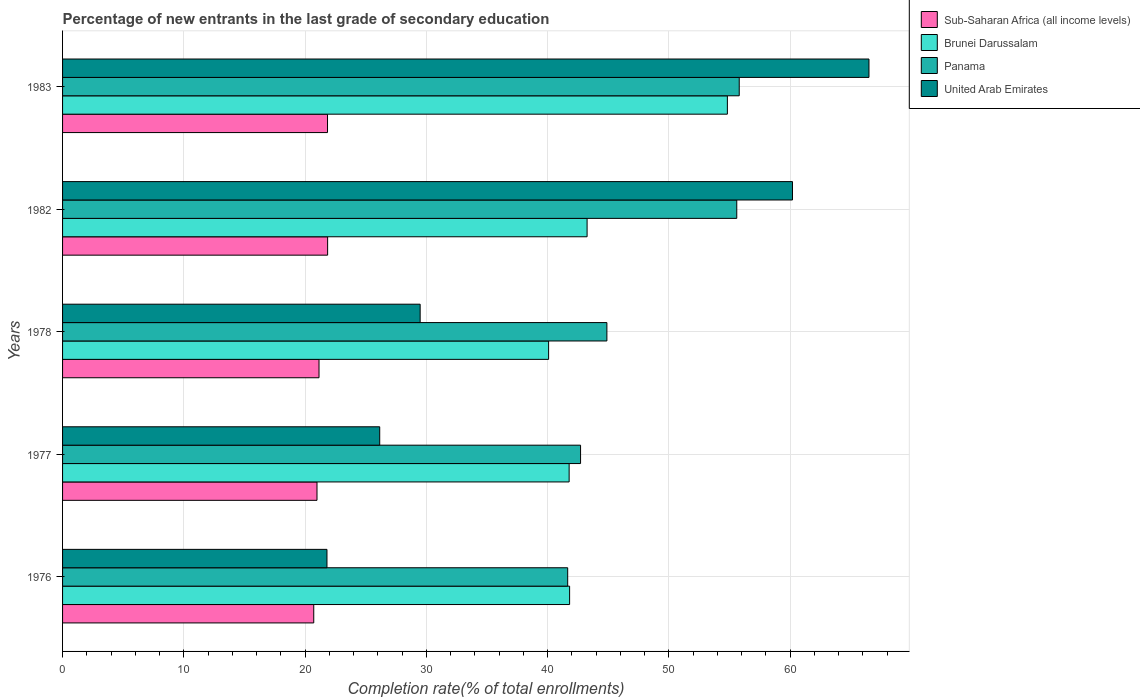How many different coloured bars are there?
Offer a terse response. 4. How many groups of bars are there?
Your response must be concise. 5. How many bars are there on the 5th tick from the bottom?
Your answer should be compact. 4. In how many cases, is the number of bars for a given year not equal to the number of legend labels?
Your response must be concise. 0. What is the percentage of new entrants in United Arab Emirates in 1982?
Offer a very short reply. 60.19. Across all years, what is the maximum percentage of new entrants in United Arab Emirates?
Your answer should be compact. 66.5. Across all years, what is the minimum percentage of new entrants in Sub-Saharan Africa (all income levels)?
Ensure brevity in your answer.  20.71. In which year was the percentage of new entrants in United Arab Emirates minimum?
Your response must be concise. 1976. What is the total percentage of new entrants in Panama in the graph?
Give a very brief answer. 240.66. What is the difference between the percentage of new entrants in Brunei Darussalam in 1976 and that in 1978?
Give a very brief answer. 1.73. What is the difference between the percentage of new entrants in United Arab Emirates in 1977 and the percentage of new entrants in Brunei Darussalam in 1983?
Ensure brevity in your answer.  -28.67. What is the average percentage of new entrants in Sub-Saharan Africa (all income levels) per year?
Provide a short and direct response. 21.31. In the year 1977, what is the difference between the percentage of new entrants in Sub-Saharan Africa (all income levels) and percentage of new entrants in Panama?
Offer a terse response. -21.73. In how many years, is the percentage of new entrants in United Arab Emirates greater than 12 %?
Your answer should be compact. 5. What is the ratio of the percentage of new entrants in United Arab Emirates in 1977 to that in 1982?
Keep it short and to the point. 0.43. Is the difference between the percentage of new entrants in Sub-Saharan Africa (all income levels) in 1976 and 1977 greater than the difference between the percentage of new entrants in Panama in 1976 and 1977?
Provide a short and direct response. Yes. What is the difference between the highest and the second highest percentage of new entrants in Sub-Saharan Africa (all income levels)?
Make the answer very short. 0.01. What is the difference between the highest and the lowest percentage of new entrants in Brunei Darussalam?
Provide a short and direct response. 14.74. Is the sum of the percentage of new entrants in United Arab Emirates in 1978 and 1983 greater than the maximum percentage of new entrants in Brunei Darussalam across all years?
Offer a very short reply. Yes. Is it the case that in every year, the sum of the percentage of new entrants in Brunei Darussalam and percentage of new entrants in Panama is greater than the sum of percentage of new entrants in United Arab Emirates and percentage of new entrants in Sub-Saharan Africa (all income levels)?
Your answer should be compact. No. What does the 3rd bar from the top in 1976 represents?
Ensure brevity in your answer.  Brunei Darussalam. What does the 3rd bar from the bottom in 1983 represents?
Give a very brief answer. Panama. Is it the case that in every year, the sum of the percentage of new entrants in United Arab Emirates and percentage of new entrants in Brunei Darussalam is greater than the percentage of new entrants in Panama?
Keep it short and to the point. Yes. How many bars are there?
Provide a succinct answer. 20. Are all the bars in the graph horizontal?
Keep it short and to the point. Yes. What is the difference between two consecutive major ticks on the X-axis?
Provide a succinct answer. 10. Are the values on the major ticks of X-axis written in scientific E-notation?
Your response must be concise. No. What is the title of the graph?
Offer a terse response. Percentage of new entrants in the last grade of secondary education. What is the label or title of the X-axis?
Give a very brief answer. Completion rate(% of total enrollments). What is the Completion rate(% of total enrollments) of Sub-Saharan Africa (all income levels) in 1976?
Make the answer very short. 20.71. What is the Completion rate(% of total enrollments) of Brunei Darussalam in 1976?
Ensure brevity in your answer.  41.81. What is the Completion rate(% of total enrollments) of Panama in 1976?
Ensure brevity in your answer.  41.65. What is the Completion rate(% of total enrollments) in United Arab Emirates in 1976?
Your answer should be very brief. 21.8. What is the Completion rate(% of total enrollments) of Sub-Saharan Africa (all income levels) in 1977?
Keep it short and to the point. 20.98. What is the Completion rate(% of total enrollments) of Brunei Darussalam in 1977?
Keep it short and to the point. 41.77. What is the Completion rate(% of total enrollments) in Panama in 1977?
Make the answer very short. 42.72. What is the Completion rate(% of total enrollments) of United Arab Emirates in 1977?
Provide a short and direct response. 26.15. What is the Completion rate(% of total enrollments) of Sub-Saharan Africa (all income levels) in 1978?
Your answer should be compact. 21.15. What is the Completion rate(% of total enrollments) in Brunei Darussalam in 1978?
Keep it short and to the point. 40.08. What is the Completion rate(% of total enrollments) in Panama in 1978?
Provide a short and direct response. 44.89. What is the Completion rate(% of total enrollments) of United Arab Emirates in 1978?
Provide a succinct answer. 29.49. What is the Completion rate(% of total enrollments) in Sub-Saharan Africa (all income levels) in 1982?
Make the answer very short. 21.86. What is the Completion rate(% of total enrollments) of Brunei Darussalam in 1982?
Give a very brief answer. 43.25. What is the Completion rate(% of total enrollments) of Panama in 1982?
Your response must be concise. 55.6. What is the Completion rate(% of total enrollments) of United Arab Emirates in 1982?
Provide a short and direct response. 60.19. What is the Completion rate(% of total enrollments) in Sub-Saharan Africa (all income levels) in 1983?
Your answer should be very brief. 21.85. What is the Completion rate(% of total enrollments) of Brunei Darussalam in 1983?
Your answer should be very brief. 54.82. What is the Completion rate(% of total enrollments) in Panama in 1983?
Your answer should be compact. 55.8. What is the Completion rate(% of total enrollments) of United Arab Emirates in 1983?
Your answer should be very brief. 66.5. Across all years, what is the maximum Completion rate(% of total enrollments) of Sub-Saharan Africa (all income levels)?
Keep it short and to the point. 21.86. Across all years, what is the maximum Completion rate(% of total enrollments) in Brunei Darussalam?
Offer a very short reply. 54.82. Across all years, what is the maximum Completion rate(% of total enrollments) in Panama?
Your response must be concise. 55.8. Across all years, what is the maximum Completion rate(% of total enrollments) of United Arab Emirates?
Provide a short and direct response. 66.5. Across all years, what is the minimum Completion rate(% of total enrollments) of Sub-Saharan Africa (all income levels)?
Offer a very short reply. 20.71. Across all years, what is the minimum Completion rate(% of total enrollments) of Brunei Darussalam?
Offer a very short reply. 40.08. Across all years, what is the minimum Completion rate(% of total enrollments) of Panama?
Keep it short and to the point. 41.65. Across all years, what is the minimum Completion rate(% of total enrollments) in United Arab Emirates?
Give a very brief answer. 21.8. What is the total Completion rate(% of total enrollments) of Sub-Saharan Africa (all income levels) in the graph?
Offer a terse response. 106.55. What is the total Completion rate(% of total enrollments) of Brunei Darussalam in the graph?
Your answer should be compact. 221.75. What is the total Completion rate(% of total enrollments) in Panama in the graph?
Offer a very short reply. 240.66. What is the total Completion rate(% of total enrollments) in United Arab Emirates in the graph?
Your response must be concise. 204.14. What is the difference between the Completion rate(% of total enrollments) in Sub-Saharan Africa (all income levels) in 1976 and that in 1977?
Offer a very short reply. -0.27. What is the difference between the Completion rate(% of total enrollments) of Brunei Darussalam in 1976 and that in 1977?
Keep it short and to the point. 0.04. What is the difference between the Completion rate(% of total enrollments) in Panama in 1976 and that in 1977?
Your response must be concise. -1.06. What is the difference between the Completion rate(% of total enrollments) of United Arab Emirates in 1976 and that in 1977?
Provide a succinct answer. -4.35. What is the difference between the Completion rate(% of total enrollments) of Sub-Saharan Africa (all income levels) in 1976 and that in 1978?
Your response must be concise. -0.43. What is the difference between the Completion rate(% of total enrollments) of Brunei Darussalam in 1976 and that in 1978?
Offer a terse response. 1.73. What is the difference between the Completion rate(% of total enrollments) of Panama in 1976 and that in 1978?
Make the answer very short. -3.23. What is the difference between the Completion rate(% of total enrollments) in United Arab Emirates in 1976 and that in 1978?
Offer a terse response. -7.68. What is the difference between the Completion rate(% of total enrollments) in Sub-Saharan Africa (all income levels) in 1976 and that in 1982?
Keep it short and to the point. -1.14. What is the difference between the Completion rate(% of total enrollments) of Brunei Darussalam in 1976 and that in 1982?
Provide a short and direct response. -1.44. What is the difference between the Completion rate(% of total enrollments) in Panama in 1976 and that in 1982?
Offer a terse response. -13.94. What is the difference between the Completion rate(% of total enrollments) of United Arab Emirates in 1976 and that in 1982?
Your answer should be very brief. -38.39. What is the difference between the Completion rate(% of total enrollments) of Sub-Saharan Africa (all income levels) in 1976 and that in 1983?
Provide a short and direct response. -1.14. What is the difference between the Completion rate(% of total enrollments) in Brunei Darussalam in 1976 and that in 1983?
Ensure brevity in your answer.  -13.01. What is the difference between the Completion rate(% of total enrollments) in Panama in 1976 and that in 1983?
Offer a very short reply. -14.15. What is the difference between the Completion rate(% of total enrollments) in United Arab Emirates in 1976 and that in 1983?
Keep it short and to the point. -44.7. What is the difference between the Completion rate(% of total enrollments) in Sub-Saharan Africa (all income levels) in 1977 and that in 1978?
Offer a terse response. -0.17. What is the difference between the Completion rate(% of total enrollments) of Brunei Darussalam in 1977 and that in 1978?
Ensure brevity in your answer.  1.69. What is the difference between the Completion rate(% of total enrollments) in Panama in 1977 and that in 1978?
Provide a short and direct response. -2.17. What is the difference between the Completion rate(% of total enrollments) in United Arab Emirates in 1977 and that in 1978?
Your response must be concise. -3.33. What is the difference between the Completion rate(% of total enrollments) of Sub-Saharan Africa (all income levels) in 1977 and that in 1982?
Give a very brief answer. -0.88. What is the difference between the Completion rate(% of total enrollments) in Brunei Darussalam in 1977 and that in 1982?
Your response must be concise. -1.48. What is the difference between the Completion rate(% of total enrollments) of Panama in 1977 and that in 1982?
Your response must be concise. -12.88. What is the difference between the Completion rate(% of total enrollments) in United Arab Emirates in 1977 and that in 1982?
Your answer should be very brief. -34.04. What is the difference between the Completion rate(% of total enrollments) of Sub-Saharan Africa (all income levels) in 1977 and that in 1983?
Give a very brief answer. -0.87. What is the difference between the Completion rate(% of total enrollments) in Brunei Darussalam in 1977 and that in 1983?
Offer a very short reply. -13.05. What is the difference between the Completion rate(% of total enrollments) in Panama in 1977 and that in 1983?
Offer a terse response. -13.09. What is the difference between the Completion rate(% of total enrollments) of United Arab Emirates in 1977 and that in 1983?
Give a very brief answer. -40.35. What is the difference between the Completion rate(% of total enrollments) in Sub-Saharan Africa (all income levels) in 1978 and that in 1982?
Ensure brevity in your answer.  -0.71. What is the difference between the Completion rate(% of total enrollments) in Brunei Darussalam in 1978 and that in 1982?
Your response must be concise. -3.17. What is the difference between the Completion rate(% of total enrollments) of Panama in 1978 and that in 1982?
Give a very brief answer. -10.71. What is the difference between the Completion rate(% of total enrollments) of United Arab Emirates in 1978 and that in 1982?
Offer a very short reply. -30.7. What is the difference between the Completion rate(% of total enrollments) in Sub-Saharan Africa (all income levels) in 1978 and that in 1983?
Your answer should be compact. -0.7. What is the difference between the Completion rate(% of total enrollments) of Brunei Darussalam in 1978 and that in 1983?
Provide a succinct answer. -14.74. What is the difference between the Completion rate(% of total enrollments) of Panama in 1978 and that in 1983?
Offer a very short reply. -10.91. What is the difference between the Completion rate(% of total enrollments) in United Arab Emirates in 1978 and that in 1983?
Your answer should be very brief. -37.01. What is the difference between the Completion rate(% of total enrollments) in Sub-Saharan Africa (all income levels) in 1982 and that in 1983?
Provide a short and direct response. 0.01. What is the difference between the Completion rate(% of total enrollments) of Brunei Darussalam in 1982 and that in 1983?
Provide a short and direct response. -11.57. What is the difference between the Completion rate(% of total enrollments) in Panama in 1982 and that in 1983?
Give a very brief answer. -0.2. What is the difference between the Completion rate(% of total enrollments) of United Arab Emirates in 1982 and that in 1983?
Offer a very short reply. -6.31. What is the difference between the Completion rate(% of total enrollments) of Sub-Saharan Africa (all income levels) in 1976 and the Completion rate(% of total enrollments) of Brunei Darussalam in 1977?
Your answer should be very brief. -21.06. What is the difference between the Completion rate(% of total enrollments) of Sub-Saharan Africa (all income levels) in 1976 and the Completion rate(% of total enrollments) of Panama in 1977?
Keep it short and to the point. -22. What is the difference between the Completion rate(% of total enrollments) in Sub-Saharan Africa (all income levels) in 1976 and the Completion rate(% of total enrollments) in United Arab Emirates in 1977?
Give a very brief answer. -5.44. What is the difference between the Completion rate(% of total enrollments) of Brunei Darussalam in 1976 and the Completion rate(% of total enrollments) of Panama in 1977?
Your response must be concise. -0.9. What is the difference between the Completion rate(% of total enrollments) of Brunei Darussalam in 1976 and the Completion rate(% of total enrollments) of United Arab Emirates in 1977?
Your answer should be very brief. 15.66. What is the difference between the Completion rate(% of total enrollments) in Panama in 1976 and the Completion rate(% of total enrollments) in United Arab Emirates in 1977?
Your response must be concise. 15.5. What is the difference between the Completion rate(% of total enrollments) of Sub-Saharan Africa (all income levels) in 1976 and the Completion rate(% of total enrollments) of Brunei Darussalam in 1978?
Offer a very short reply. -19.37. What is the difference between the Completion rate(% of total enrollments) of Sub-Saharan Africa (all income levels) in 1976 and the Completion rate(% of total enrollments) of Panama in 1978?
Offer a very short reply. -24.17. What is the difference between the Completion rate(% of total enrollments) in Sub-Saharan Africa (all income levels) in 1976 and the Completion rate(% of total enrollments) in United Arab Emirates in 1978?
Ensure brevity in your answer.  -8.77. What is the difference between the Completion rate(% of total enrollments) in Brunei Darussalam in 1976 and the Completion rate(% of total enrollments) in Panama in 1978?
Keep it short and to the point. -3.07. What is the difference between the Completion rate(% of total enrollments) in Brunei Darussalam in 1976 and the Completion rate(% of total enrollments) in United Arab Emirates in 1978?
Make the answer very short. 12.33. What is the difference between the Completion rate(% of total enrollments) in Panama in 1976 and the Completion rate(% of total enrollments) in United Arab Emirates in 1978?
Provide a succinct answer. 12.17. What is the difference between the Completion rate(% of total enrollments) in Sub-Saharan Africa (all income levels) in 1976 and the Completion rate(% of total enrollments) in Brunei Darussalam in 1982?
Give a very brief answer. -22.54. What is the difference between the Completion rate(% of total enrollments) in Sub-Saharan Africa (all income levels) in 1976 and the Completion rate(% of total enrollments) in Panama in 1982?
Make the answer very short. -34.88. What is the difference between the Completion rate(% of total enrollments) in Sub-Saharan Africa (all income levels) in 1976 and the Completion rate(% of total enrollments) in United Arab Emirates in 1982?
Make the answer very short. -39.48. What is the difference between the Completion rate(% of total enrollments) of Brunei Darussalam in 1976 and the Completion rate(% of total enrollments) of Panama in 1982?
Your response must be concise. -13.78. What is the difference between the Completion rate(% of total enrollments) of Brunei Darussalam in 1976 and the Completion rate(% of total enrollments) of United Arab Emirates in 1982?
Offer a very short reply. -18.38. What is the difference between the Completion rate(% of total enrollments) of Panama in 1976 and the Completion rate(% of total enrollments) of United Arab Emirates in 1982?
Your response must be concise. -18.54. What is the difference between the Completion rate(% of total enrollments) of Sub-Saharan Africa (all income levels) in 1976 and the Completion rate(% of total enrollments) of Brunei Darussalam in 1983?
Offer a very short reply. -34.11. What is the difference between the Completion rate(% of total enrollments) in Sub-Saharan Africa (all income levels) in 1976 and the Completion rate(% of total enrollments) in Panama in 1983?
Your answer should be compact. -35.09. What is the difference between the Completion rate(% of total enrollments) of Sub-Saharan Africa (all income levels) in 1976 and the Completion rate(% of total enrollments) of United Arab Emirates in 1983?
Make the answer very short. -45.79. What is the difference between the Completion rate(% of total enrollments) in Brunei Darussalam in 1976 and the Completion rate(% of total enrollments) in Panama in 1983?
Provide a short and direct response. -13.99. What is the difference between the Completion rate(% of total enrollments) in Brunei Darussalam in 1976 and the Completion rate(% of total enrollments) in United Arab Emirates in 1983?
Your answer should be very brief. -24.69. What is the difference between the Completion rate(% of total enrollments) of Panama in 1976 and the Completion rate(% of total enrollments) of United Arab Emirates in 1983?
Offer a terse response. -24.84. What is the difference between the Completion rate(% of total enrollments) of Sub-Saharan Africa (all income levels) in 1977 and the Completion rate(% of total enrollments) of Brunei Darussalam in 1978?
Your answer should be compact. -19.1. What is the difference between the Completion rate(% of total enrollments) in Sub-Saharan Africa (all income levels) in 1977 and the Completion rate(% of total enrollments) in Panama in 1978?
Provide a short and direct response. -23.91. What is the difference between the Completion rate(% of total enrollments) of Sub-Saharan Africa (all income levels) in 1977 and the Completion rate(% of total enrollments) of United Arab Emirates in 1978?
Give a very brief answer. -8.51. What is the difference between the Completion rate(% of total enrollments) in Brunei Darussalam in 1977 and the Completion rate(% of total enrollments) in Panama in 1978?
Your answer should be very brief. -3.11. What is the difference between the Completion rate(% of total enrollments) in Brunei Darussalam in 1977 and the Completion rate(% of total enrollments) in United Arab Emirates in 1978?
Offer a terse response. 12.29. What is the difference between the Completion rate(% of total enrollments) of Panama in 1977 and the Completion rate(% of total enrollments) of United Arab Emirates in 1978?
Your answer should be compact. 13.23. What is the difference between the Completion rate(% of total enrollments) in Sub-Saharan Africa (all income levels) in 1977 and the Completion rate(% of total enrollments) in Brunei Darussalam in 1982?
Your answer should be compact. -22.27. What is the difference between the Completion rate(% of total enrollments) of Sub-Saharan Africa (all income levels) in 1977 and the Completion rate(% of total enrollments) of Panama in 1982?
Make the answer very short. -34.62. What is the difference between the Completion rate(% of total enrollments) in Sub-Saharan Africa (all income levels) in 1977 and the Completion rate(% of total enrollments) in United Arab Emirates in 1982?
Give a very brief answer. -39.21. What is the difference between the Completion rate(% of total enrollments) in Brunei Darussalam in 1977 and the Completion rate(% of total enrollments) in Panama in 1982?
Offer a terse response. -13.82. What is the difference between the Completion rate(% of total enrollments) in Brunei Darussalam in 1977 and the Completion rate(% of total enrollments) in United Arab Emirates in 1982?
Your answer should be compact. -18.42. What is the difference between the Completion rate(% of total enrollments) in Panama in 1977 and the Completion rate(% of total enrollments) in United Arab Emirates in 1982?
Your answer should be compact. -17.48. What is the difference between the Completion rate(% of total enrollments) of Sub-Saharan Africa (all income levels) in 1977 and the Completion rate(% of total enrollments) of Brunei Darussalam in 1983?
Keep it short and to the point. -33.84. What is the difference between the Completion rate(% of total enrollments) in Sub-Saharan Africa (all income levels) in 1977 and the Completion rate(% of total enrollments) in Panama in 1983?
Your answer should be very brief. -34.82. What is the difference between the Completion rate(% of total enrollments) in Sub-Saharan Africa (all income levels) in 1977 and the Completion rate(% of total enrollments) in United Arab Emirates in 1983?
Your answer should be very brief. -45.52. What is the difference between the Completion rate(% of total enrollments) in Brunei Darussalam in 1977 and the Completion rate(% of total enrollments) in Panama in 1983?
Your answer should be compact. -14.03. What is the difference between the Completion rate(% of total enrollments) in Brunei Darussalam in 1977 and the Completion rate(% of total enrollments) in United Arab Emirates in 1983?
Offer a terse response. -24.73. What is the difference between the Completion rate(% of total enrollments) of Panama in 1977 and the Completion rate(% of total enrollments) of United Arab Emirates in 1983?
Make the answer very short. -23.78. What is the difference between the Completion rate(% of total enrollments) of Sub-Saharan Africa (all income levels) in 1978 and the Completion rate(% of total enrollments) of Brunei Darussalam in 1982?
Your answer should be very brief. -22.11. What is the difference between the Completion rate(% of total enrollments) of Sub-Saharan Africa (all income levels) in 1978 and the Completion rate(% of total enrollments) of Panama in 1982?
Provide a short and direct response. -34.45. What is the difference between the Completion rate(% of total enrollments) in Sub-Saharan Africa (all income levels) in 1978 and the Completion rate(% of total enrollments) in United Arab Emirates in 1982?
Ensure brevity in your answer.  -39.04. What is the difference between the Completion rate(% of total enrollments) in Brunei Darussalam in 1978 and the Completion rate(% of total enrollments) in Panama in 1982?
Keep it short and to the point. -15.52. What is the difference between the Completion rate(% of total enrollments) of Brunei Darussalam in 1978 and the Completion rate(% of total enrollments) of United Arab Emirates in 1982?
Make the answer very short. -20.11. What is the difference between the Completion rate(% of total enrollments) in Panama in 1978 and the Completion rate(% of total enrollments) in United Arab Emirates in 1982?
Provide a short and direct response. -15.3. What is the difference between the Completion rate(% of total enrollments) in Sub-Saharan Africa (all income levels) in 1978 and the Completion rate(% of total enrollments) in Brunei Darussalam in 1983?
Make the answer very short. -33.67. What is the difference between the Completion rate(% of total enrollments) in Sub-Saharan Africa (all income levels) in 1978 and the Completion rate(% of total enrollments) in Panama in 1983?
Provide a succinct answer. -34.65. What is the difference between the Completion rate(% of total enrollments) in Sub-Saharan Africa (all income levels) in 1978 and the Completion rate(% of total enrollments) in United Arab Emirates in 1983?
Your answer should be compact. -45.35. What is the difference between the Completion rate(% of total enrollments) in Brunei Darussalam in 1978 and the Completion rate(% of total enrollments) in Panama in 1983?
Your response must be concise. -15.72. What is the difference between the Completion rate(% of total enrollments) in Brunei Darussalam in 1978 and the Completion rate(% of total enrollments) in United Arab Emirates in 1983?
Provide a succinct answer. -26.42. What is the difference between the Completion rate(% of total enrollments) in Panama in 1978 and the Completion rate(% of total enrollments) in United Arab Emirates in 1983?
Offer a very short reply. -21.61. What is the difference between the Completion rate(% of total enrollments) in Sub-Saharan Africa (all income levels) in 1982 and the Completion rate(% of total enrollments) in Brunei Darussalam in 1983?
Provide a short and direct response. -32.97. What is the difference between the Completion rate(% of total enrollments) in Sub-Saharan Africa (all income levels) in 1982 and the Completion rate(% of total enrollments) in Panama in 1983?
Offer a terse response. -33.94. What is the difference between the Completion rate(% of total enrollments) of Sub-Saharan Africa (all income levels) in 1982 and the Completion rate(% of total enrollments) of United Arab Emirates in 1983?
Your answer should be compact. -44.64. What is the difference between the Completion rate(% of total enrollments) of Brunei Darussalam in 1982 and the Completion rate(% of total enrollments) of Panama in 1983?
Give a very brief answer. -12.55. What is the difference between the Completion rate(% of total enrollments) of Brunei Darussalam in 1982 and the Completion rate(% of total enrollments) of United Arab Emirates in 1983?
Make the answer very short. -23.24. What is the difference between the Completion rate(% of total enrollments) of Panama in 1982 and the Completion rate(% of total enrollments) of United Arab Emirates in 1983?
Your answer should be compact. -10.9. What is the average Completion rate(% of total enrollments) in Sub-Saharan Africa (all income levels) per year?
Provide a succinct answer. 21.31. What is the average Completion rate(% of total enrollments) in Brunei Darussalam per year?
Your answer should be very brief. 44.35. What is the average Completion rate(% of total enrollments) in Panama per year?
Your response must be concise. 48.13. What is the average Completion rate(% of total enrollments) of United Arab Emirates per year?
Offer a terse response. 40.83. In the year 1976, what is the difference between the Completion rate(% of total enrollments) in Sub-Saharan Africa (all income levels) and Completion rate(% of total enrollments) in Brunei Darussalam?
Make the answer very short. -21.1. In the year 1976, what is the difference between the Completion rate(% of total enrollments) of Sub-Saharan Africa (all income levels) and Completion rate(% of total enrollments) of Panama?
Provide a succinct answer. -20.94. In the year 1976, what is the difference between the Completion rate(% of total enrollments) of Sub-Saharan Africa (all income levels) and Completion rate(% of total enrollments) of United Arab Emirates?
Provide a short and direct response. -1.09. In the year 1976, what is the difference between the Completion rate(% of total enrollments) in Brunei Darussalam and Completion rate(% of total enrollments) in Panama?
Ensure brevity in your answer.  0.16. In the year 1976, what is the difference between the Completion rate(% of total enrollments) of Brunei Darussalam and Completion rate(% of total enrollments) of United Arab Emirates?
Provide a short and direct response. 20.01. In the year 1976, what is the difference between the Completion rate(% of total enrollments) in Panama and Completion rate(% of total enrollments) in United Arab Emirates?
Ensure brevity in your answer.  19.85. In the year 1977, what is the difference between the Completion rate(% of total enrollments) of Sub-Saharan Africa (all income levels) and Completion rate(% of total enrollments) of Brunei Darussalam?
Your response must be concise. -20.79. In the year 1977, what is the difference between the Completion rate(% of total enrollments) of Sub-Saharan Africa (all income levels) and Completion rate(% of total enrollments) of Panama?
Your response must be concise. -21.73. In the year 1977, what is the difference between the Completion rate(% of total enrollments) of Sub-Saharan Africa (all income levels) and Completion rate(% of total enrollments) of United Arab Emirates?
Offer a terse response. -5.17. In the year 1977, what is the difference between the Completion rate(% of total enrollments) of Brunei Darussalam and Completion rate(% of total enrollments) of Panama?
Ensure brevity in your answer.  -0.94. In the year 1977, what is the difference between the Completion rate(% of total enrollments) in Brunei Darussalam and Completion rate(% of total enrollments) in United Arab Emirates?
Provide a short and direct response. 15.62. In the year 1977, what is the difference between the Completion rate(% of total enrollments) in Panama and Completion rate(% of total enrollments) in United Arab Emirates?
Give a very brief answer. 16.56. In the year 1978, what is the difference between the Completion rate(% of total enrollments) in Sub-Saharan Africa (all income levels) and Completion rate(% of total enrollments) in Brunei Darussalam?
Your answer should be compact. -18.93. In the year 1978, what is the difference between the Completion rate(% of total enrollments) of Sub-Saharan Africa (all income levels) and Completion rate(% of total enrollments) of Panama?
Your answer should be very brief. -23.74. In the year 1978, what is the difference between the Completion rate(% of total enrollments) in Sub-Saharan Africa (all income levels) and Completion rate(% of total enrollments) in United Arab Emirates?
Offer a terse response. -8.34. In the year 1978, what is the difference between the Completion rate(% of total enrollments) in Brunei Darussalam and Completion rate(% of total enrollments) in Panama?
Ensure brevity in your answer.  -4.81. In the year 1978, what is the difference between the Completion rate(% of total enrollments) of Brunei Darussalam and Completion rate(% of total enrollments) of United Arab Emirates?
Ensure brevity in your answer.  10.59. In the year 1978, what is the difference between the Completion rate(% of total enrollments) of Panama and Completion rate(% of total enrollments) of United Arab Emirates?
Offer a very short reply. 15.4. In the year 1982, what is the difference between the Completion rate(% of total enrollments) of Sub-Saharan Africa (all income levels) and Completion rate(% of total enrollments) of Brunei Darussalam?
Your answer should be compact. -21.4. In the year 1982, what is the difference between the Completion rate(% of total enrollments) of Sub-Saharan Africa (all income levels) and Completion rate(% of total enrollments) of Panama?
Provide a succinct answer. -33.74. In the year 1982, what is the difference between the Completion rate(% of total enrollments) of Sub-Saharan Africa (all income levels) and Completion rate(% of total enrollments) of United Arab Emirates?
Your answer should be compact. -38.33. In the year 1982, what is the difference between the Completion rate(% of total enrollments) of Brunei Darussalam and Completion rate(% of total enrollments) of Panama?
Keep it short and to the point. -12.34. In the year 1982, what is the difference between the Completion rate(% of total enrollments) in Brunei Darussalam and Completion rate(% of total enrollments) in United Arab Emirates?
Ensure brevity in your answer.  -16.94. In the year 1982, what is the difference between the Completion rate(% of total enrollments) of Panama and Completion rate(% of total enrollments) of United Arab Emirates?
Your answer should be very brief. -4.59. In the year 1983, what is the difference between the Completion rate(% of total enrollments) in Sub-Saharan Africa (all income levels) and Completion rate(% of total enrollments) in Brunei Darussalam?
Offer a terse response. -32.97. In the year 1983, what is the difference between the Completion rate(% of total enrollments) of Sub-Saharan Africa (all income levels) and Completion rate(% of total enrollments) of Panama?
Your response must be concise. -33.95. In the year 1983, what is the difference between the Completion rate(% of total enrollments) in Sub-Saharan Africa (all income levels) and Completion rate(% of total enrollments) in United Arab Emirates?
Offer a very short reply. -44.65. In the year 1983, what is the difference between the Completion rate(% of total enrollments) of Brunei Darussalam and Completion rate(% of total enrollments) of Panama?
Keep it short and to the point. -0.98. In the year 1983, what is the difference between the Completion rate(% of total enrollments) in Brunei Darussalam and Completion rate(% of total enrollments) in United Arab Emirates?
Offer a terse response. -11.68. In the year 1983, what is the difference between the Completion rate(% of total enrollments) of Panama and Completion rate(% of total enrollments) of United Arab Emirates?
Your answer should be very brief. -10.7. What is the ratio of the Completion rate(% of total enrollments) in Sub-Saharan Africa (all income levels) in 1976 to that in 1977?
Give a very brief answer. 0.99. What is the ratio of the Completion rate(% of total enrollments) in Brunei Darussalam in 1976 to that in 1977?
Provide a succinct answer. 1. What is the ratio of the Completion rate(% of total enrollments) of Panama in 1976 to that in 1977?
Keep it short and to the point. 0.98. What is the ratio of the Completion rate(% of total enrollments) in United Arab Emirates in 1976 to that in 1977?
Give a very brief answer. 0.83. What is the ratio of the Completion rate(% of total enrollments) of Sub-Saharan Africa (all income levels) in 1976 to that in 1978?
Provide a succinct answer. 0.98. What is the ratio of the Completion rate(% of total enrollments) of Brunei Darussalam in 1976 to that in 1978?
Your answer should be very brief. 1.04. What is the ratio of the Completion rate(% of total enrollments) of Panama in 1976 to that in 1978?
Make the answer very short. 0.93. What is the ratio of the Completion rate(% of total enrollments) of United Arab Emirates in 1976 to that in 1978?
Your response must be concise. 0.74. What is the ratio of the Completion rate(% of total enrollments) of Sub-Saharan Africa (all income levels) in 1976 to that in 1982?
Keep it short and to the point. 0.95. What is the ratio of the Completion rate(% of total enrollments) in Brunei Darussalam in 1976 to that in 1982?
Ensure brevity in your answer.  0.97. What is the ratio of the Completion rate(% of total enrollments) of Panama in 1976 to that in 1982?
Give a very brief answer. 0.75. What is the ratio of the Completion rate(% of total enrollments) of United Arab Emirates in 1976 to that in 1982?
Ensure brevity in your answer.  0.36. What is the ratio of the Completion rate(% of total enrollments) in Sub-Saharan Africa (all income levels) in 1976 to that in 1983?
Your answer should be compact. 0.95. What is the ratio of the Completion rate(% of total enrollments) in Brunei Darussalam in 1976 to that in 1983?
Give a very brief answer. 0.76. What is the ratio of the Completion rate(% of total enrollments) of Panama in 1976 to that in 1983?
Ensure brevity in your answer.  0.75. What is the ratio of the Completion rate(% of total enrollments) in United Arab Emirates in 1976 to that in 1983?
Make the answer very short. 0.33. What is the ratio of the Completion rate(% of total enrollments) of Brunei Darussalam in 1977 to that in 1978?
Offer a terse response. 1.04. What is the ratio of the Completion rate(% of total enrollments) in Panama in 1977 to that in 1978?
Your response must be concise. 0.95. What is the ratio of the Completion rate(% of total enrollments) in United Arab Emirates in 1977 to that in 1978?
Your answer should be compact. 0.89. What is the ratio of the Completion rate(% of total enrollments) in Sub-Saharan Africa (all income levels) in 1977 to that in 1982?
Provide a short and direct response. 0.96. What is the ratio of the Completion rate(% of total enrollments) in Brunei Darussalam in 1977 to that in 1982?
Make the answer very short. 0.97. What is the ratio of the Completion rate(% of total enrollments) in Panama in 1977 to that in 1982?
Your response must be concise. 0.77. What is the ratio of the Completion rate(% of total enrollments) in United Arab Emirates in 1977 to that in 1982?
Offer a very short reply. 0.43. What is the ratio of the Completion rate(% of total enrollments) in Sub-Saharan Africa (all income levels) in 1977 to that in 1983?
Provide a short and direct response. 0.96. What is the ratio of the Completion rate(% of total enrollments) in Brunei Darussalam in 1977 to that in 1983?
Provide a short and direct response. 0.76. What is the ratio of the Completion rate(% of total enrollments) of Panama in 1977 to that in 1983?
Your answer should be very brief. 0.77. What is the ratio of the Completion rate(% of total enrollments) in United Arab Emirates in 1977 to that in 1983?
Provide a succinct answer. 0.39. What is the ratio of the Completion rate(% of total enrollments) of Sub-Saharan Africa (all income levels) in 1978 to that in 1982?
Provide a succinct answer. 0.97. What is the ratio of the Completion rate(% of total enrollments) in Brunei Darussalam in 1978 to that in 1982?
Give a very brief answer. 0.93. What is the ratio of the Completion rate(% of total enrollments) in Panama in 1978 to that in 1982?
Provide a short and direct response. 0.81. What is the ratio of the Completion rate(% of total enrollments) of United Arab Emirates in 1978 to that in 1982?
Keep it short and to the point. 0.49. What is the ratio of the Completion rate(% of total enrollments) of Sub-Saharan Africa (all income levels) in 1978 to that in 1983?
Ensure brevity in your answer.  0.97. What is the ratio of the Completion rate(% of total enrollments) of Brunei Darussalam in 1978 to that in 1983?
Ensure brevity in your answer.  0.73. What is the ratio of the Completion rate(% of total enrollments) of Panama in 1978 to that in 1983?
Your response must be concise. 0.8. What is the ratio of the Completion rate(% of total enrollments) of United Arab Emirates in 1978 to that in 1983?
Provide a short and direct response. 0.44. What is the ratio of the Completion rate(% of total enrollments) of Sub-Saharan Africa (all income levels) in 1982 to that in 1983?
Provide a short and direct response. 1. What is the ratio of the Completion rate(% of total enrollments) of Brunei Darussalam in 1982 to that in 1983?
Make the answer very short. 0.79. What is the ratio of the Completion rate(% of total enrollments) of Panama in 1982 to that in 1983?
Your answer should be very brief. 1. What is the ratio of the Completion rate(% of total enrollments) in United Arab Emirates in 1982 to that in 1983?
Provide a short and direct response. 0.91. What is the difference between the highest and the second highest Completion rate(% of total enrollments) in Sub-Saharan Africa (all income levels)?
Ensure brevity in your answer.  0.01. What is the difference between the highest and the second highest Completion rate(% of total enrollments) of Brunei Darussalam?
Provide a succinct answer. 11.57. What is the difference between the highest and the second highest Completion rate(% of total enrollments) of Panama?
Your response must be concise. 0.2. What is the difference between the highest and the second highest Completion rate(% of total enrollments) of United Arab Emirates?
Your answer should be compact. 6.31. What is the difference between the highest and the lowest Completion rate(% of total enrollments) in Sub-Saharan Africa (all income levels)?
Your response must be concise. 1.14. What is the difference between the highest and the lowest Completion rate(% of total enrollments) in Brunei Darussalam?
Provide a succinct answer. 14.74. What is the difference between the highest and the lowest Completion rate(% of total enrollments) in Panama?
Ensure brevity in your answer.  14.15. What is the difference between the highest and the lowest Completion rate(% of total enrollments) in United Arab Emirates?
Offer a terse response. 44.7. 